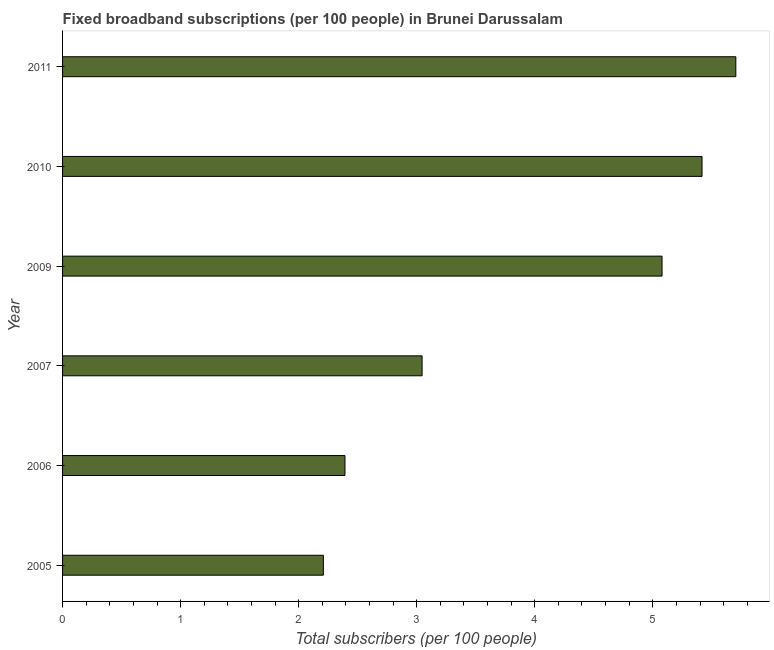Does the graph contain grids?
Give a very brief answer. No. What is the title of the graph?
Provide a succinct answer. Fixed broadband subscriptions (per 100 people) in Brunei Darussalam. What is the label or title of the X-axis?
Ensure brevity in your answer.  Total subscribers (per 100 people). What is the total number of fixed broadband subscriptions in 2010?
Your answer should be very brief. 5.42. Across all years, what is the maximum total number of fixed broadband subscriptions?
Your answer should be very brief. 5.7. Across all years, what is the minimum total number of fixed broadband subscriptions?
Offer a very short reply. 2.21. What is the sum of the total number of fixed broadband subscriptions?
Your answer should be very brief. 23.85. What is the difference between the total number of fixed broadband subscriptions in 2009 and 2010?
Your answer should be compact. -0.34. What is the average total number of fixed broadband subscriptions per year?
Offer a terse response. 3.97. What is the median total number of fixed broadband subscriptions?
Provide a short and direct response. 4.06. In how many years, is the total number of fixed broadband subscriptions greater than 5.4 ?
Make the answer very short. 2. Do a majority of the years between 2006 and 2011 (inclusive) have total number of fixed broadband subscriptions greater than 0.2 ?
Make the answer very short. Yes. What is the ratio of the total number of fixed broadband subscriptions in 2006 to that in 2007?
Provide a short and direct response. 0.79. Is the total number of fixed broadband subscriptions in 2006 less than that in 2010?
Offer a terse response. Yes. Is the difference between the total number of fixed broadband subscriptions in 2006 and 2010 greater than the difference between any two years?
Make the answer very short. No. What is the difference between the highest and the second highest total number of fixed broadband subscriptions?
Give a very brief answer. 0.29. Is the sum of the total number of fixed broadband subscriptions in 2005 and 2009 greater than the maximum total number of fixed broadband subscriptions across all years?
Provide a short and direct response. Yes. What is the difference between the highest and the lowest total number of fixed broadband subscriptions?
Your response must be concise. 3.49. Are all the bars in the graph horizontal?
Provide a succinct answer. Yes. What is the Total subscribers (per 100 people) in 2005?
Your response must be concise. 2.21. What is the Total subscribers (per 100 people) in 2006?
Provide a short and direct response. 2.39. What is the Total subscribers (per 100 people) in 2007?
Give a very brief answer. 3.05. What is the Total subscribers (per 100 people) in 2009?
Offer a terse response. 5.08. What is the Total subscribers (per 100 people) in 2010?
Your answer should be compact. 5.42. What is the Total subscribers (per 100 people) in 2011?
Ensure brevity in your answer.  5.7. What is the difference between the Total subscribers (per 100 people) in 2005 and 2006?
Provide a succinct answer. -0.18. What is the difference between the Total subscribers (per 100 people) in 2005 and 2007?
Ensure brevity in your answer.  -0.84. What is the difference between the Total subscribers (per 100 people) in 2005 and 2009?
Keep it short and to the point. -2.87. What is the difference between the Total subscribers (per 100 people) in 2005 and 2010?
Give a very brief answer. -3.21. What is the difference between the Total subscribers (per 100 people) in 2005 and 2011?
Ensure brevity in your answer.  -3.49. What is the difference between the Total subscribers (per 100 people) in 2006 and 2007?
Make the answer very short. -0.65. What is the difference between the Total subscribers (per 100 people) in 2006 and 2009?
Your response must be concise. -2.69. What is the difference between the Total subscribers (per 100 people) in 2006 and 2010?
Make the answer very short. -3.02. What is the difference between the Total subscribers (per 100 people) in 2006 and 2011?
Give a very brief answer. -3.31. What is the difference between the Total subscribers (per 100 people) in 2007 and 2009?
Keep it short and to the point. -2.03. What is the difference between the Total subscribers (per 100 people) in 2007 and 2010?
Your answer should be very brief. -2.37. What is the difference between the Total subscribers (per 100 people) in 2007 and 2011?
Give a very brief answer. -2.66. What is the difference between the Total subscribers (per 100 people) in 2009 and 2010?
Your answer should be very brief. -0.34. What is the difference between the Total subscribers (per 100 people) in 2009 and 2011?
Ensure brevity in your answer.  -0.63. What is the difference between the Total subscribers (per 100 people) in 2010 and 2011?
Make the answer very short. -0.29. What is the ratio of the Total subscribers (per 100 people) in 2005 to that in 2006?
Offer a terse response. 0.92. What is the ratio of the Total subscribers (per 100 people) in 2005 to that in 2007?
Keep it short and to the point. 0.72. What is the ratio of the Total subscribers (per 100 people) in 2005 to that in 2009?
Provide a succinct answer. 0.43. What is the ratio of the Total subscribers (per 100 people) in 2005 to that in 2010?
Keep it short and to the point. 0.41. What is the ratio of the Total subscribers (per 100 people) in 2005 to that in 2011?
Your answer should be very brief. 0.39. What is the ratio of the Total subscribers (per 100 people) in 2006 to that in 2007?
Keep it short and to the point. 0.79. What is the ratio of the Total subscribers (per 100 people) in 2006 to that in 2009?
Offer a terse response. 0.47. What is the ratio of the Total subscribers (per 100 people) in 2006 to that in 2010?
Ensure brevity in your answer.  0.44. What is the ratio of the Total subscribers (per 100 people) in 2006 to that in 2011?
Ensure brevity in your answer.  0.42. What is the ratio of the Total subscribers (per 100 people) in 2007 to that in 2010?
Give a very brief answer. 0.56. What is the ratio of the Total subscribers (per 100 people) in 2007 to that in 2011?
Provide a succinct answer. 0.53. What is the ratio of the Total subscribers (per 100 people) in 2009 to that in 2010?
Keep it short and to the point. 0.94. What is the ratio of the Total subscribers (per 100 people) in 2009 to that in 2011?
Your answer should be very brief. 0.89. 